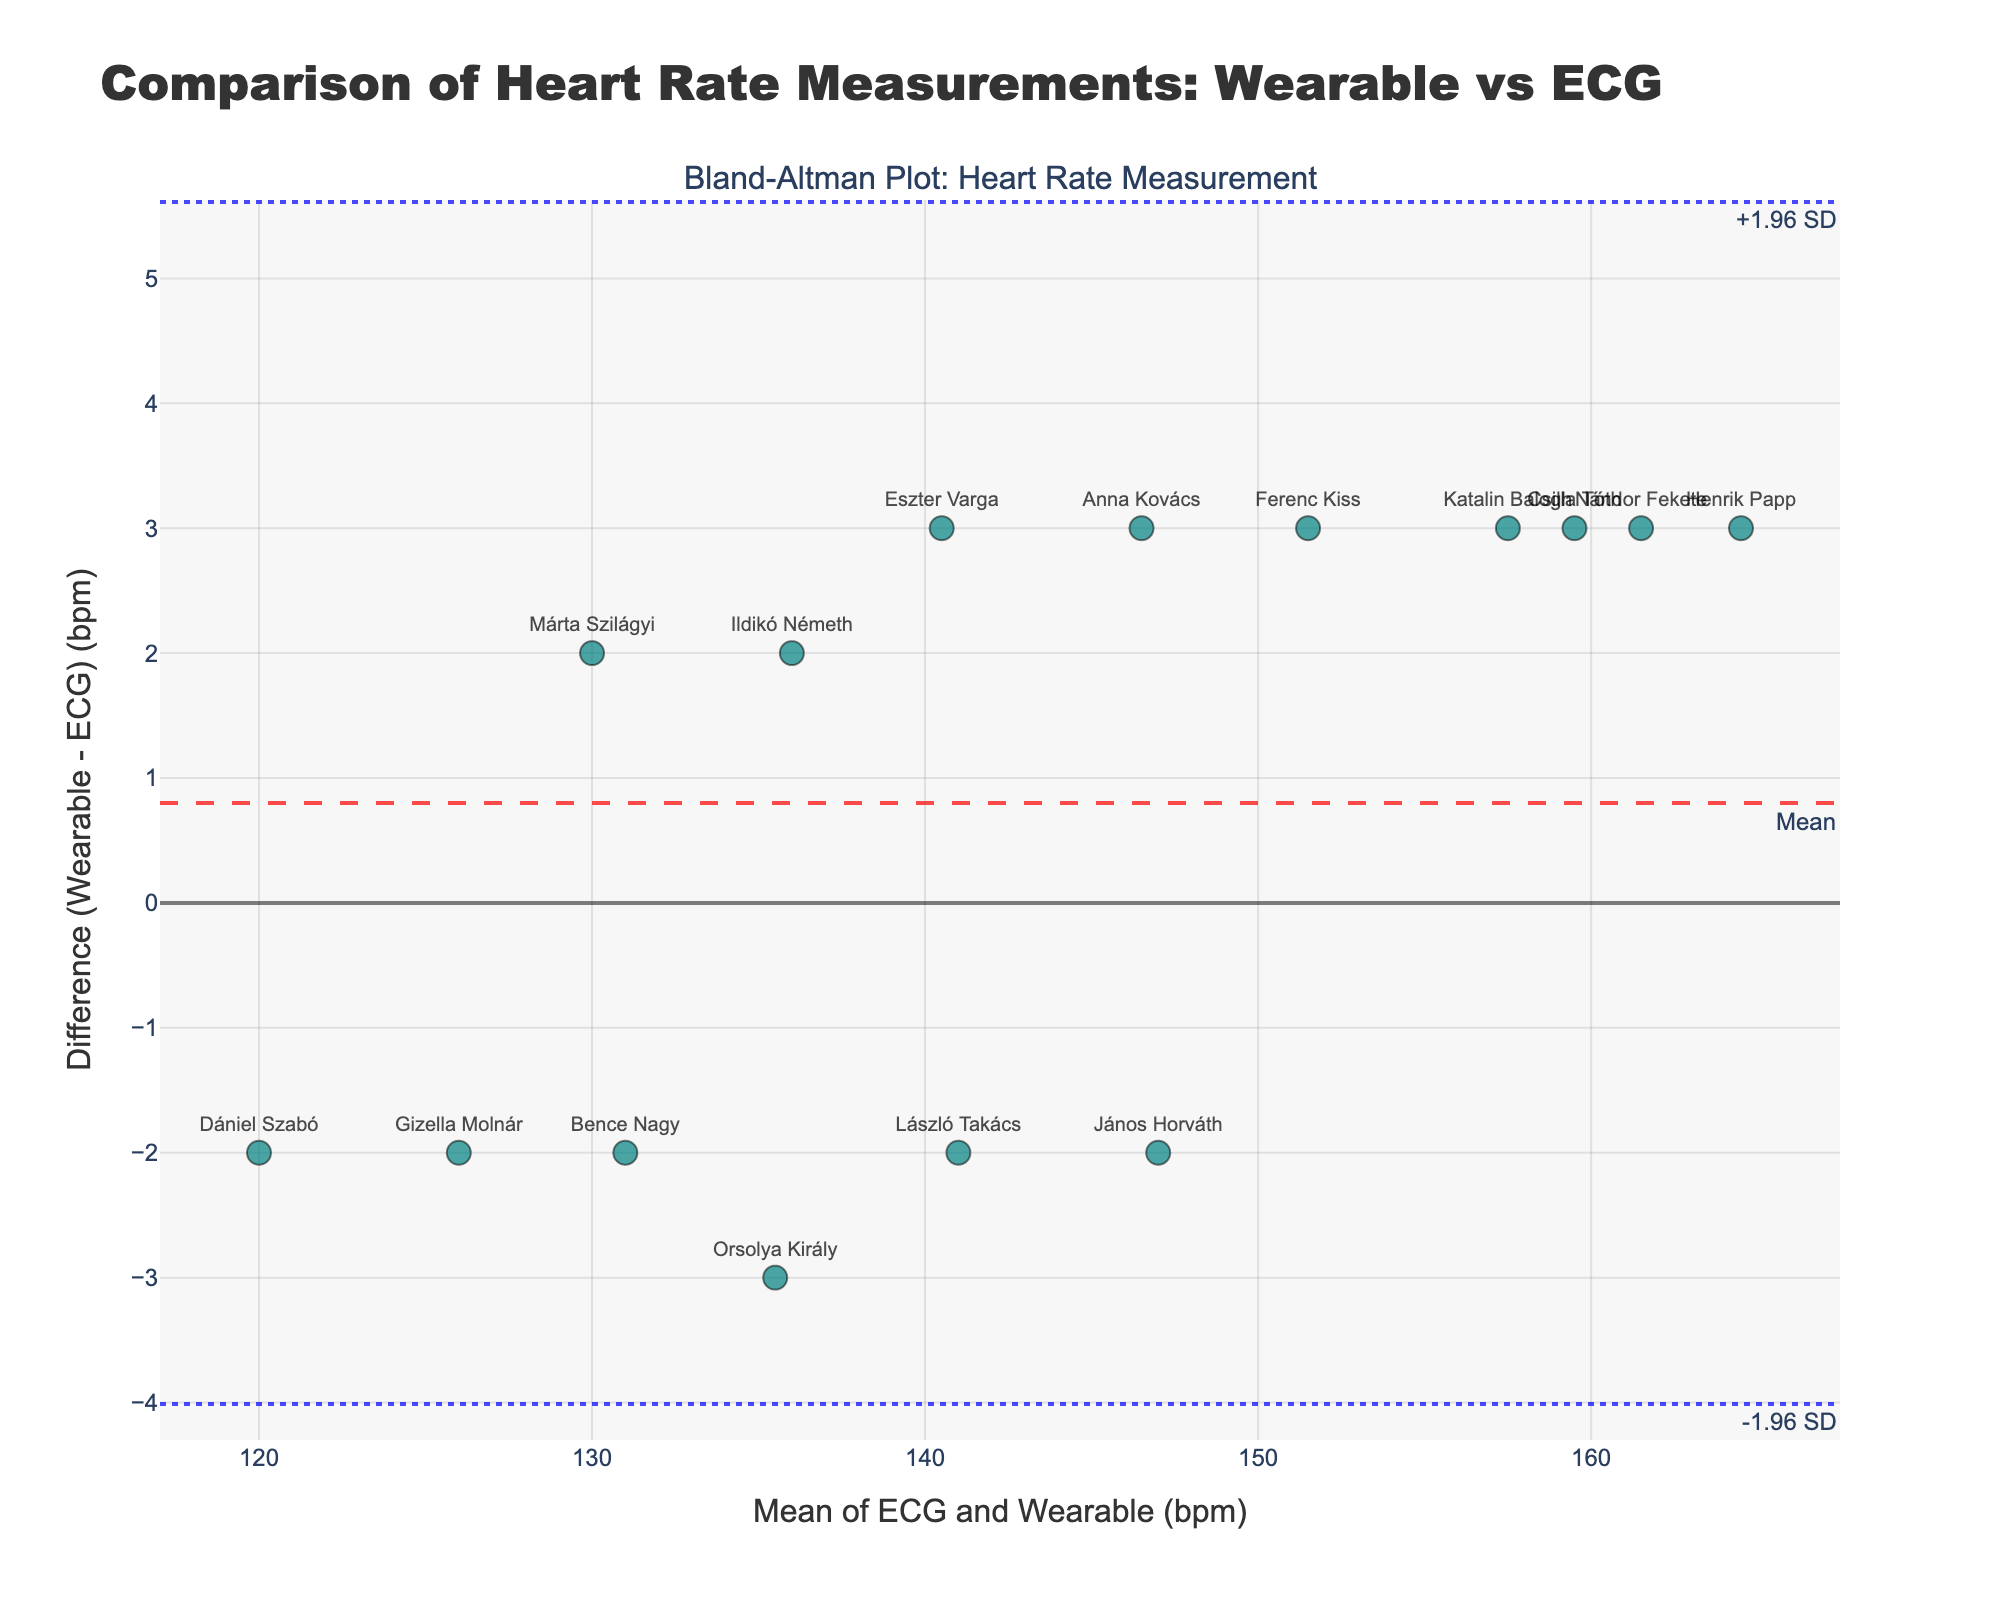What is the title of the plot? The title is generally found at the top of the plot, which provides a brief description of what the plot represents. This helps in quickly understanding the main focus of the figure.
Answer: Comparison of Heart Rate Measurements: Wearable vs ECG What do the x-axis and y-axis represent in the plot? The labels on the axes usually describe what each axis represents. The x-axis label is "Mean of ECG and Wearable (bpm)", and the y-axis label is "Difference (Wearable - ECG) (bpm)".
Answer: The x-axis represents "Mean of ECG and Wearable (bpm)", and the y-axis represents "Difference (Wearable - ECG) (bpm)" How many data points are there in the plot? By counting the number of markers or data points in the scatter part of the plot, we can determine how many individual measurements were compared.
Answer: 15 What is the mean difference between heart rate measurements by the wearable device and ECG? The mean difference line is typically highlighted in the plot, often annotated. This represents the average discrepancy between the two measurement methods.
Answer: Mean difference is around 2 bpm What are the upper and lower limits of agreement? The Bland-Altman plot usually shows the limits of agreement using dotted lines and often annotated. These limits are calculated as mean difference ± 1.96 * standard deviation of the differences.
Answer: Upper limit is approximately 5.92 bpm, and lower limit is approximately -1.92 bpm Which player has the largest difference between wearable and ECG measurements? By looking at the y-axis values of each data point and identifying the extreme value, we can determine which player has the maximum discrepancy.
Answer: Henrik Papp Who has the smallest difference between wearable and ECG measurements? Similarly, by identifying the data point closest to 0 on the y-axis, we can find the player with the smallest measurement difference.
Answer: László Takács What is the average heart rate measured by both devices for Ildikó Németh? Use Ildikó Németh's data point to find the average heart rate from the plotted mean value on the x-axis.
Answer: 136 bpm Is there any player whose difference is below the lower limit of agreement? Check if any data points fall below the lower limit of agreement line. This would identify outliers or significant discrepancies.
Answer: No What can you deduce if most data points lie within the limits of agreement? If most data points lie within ±1.96 standard deviations of the mean difference, it indicates good agreement between the two measurement methods. This means the wearable device is reasonably consistent with the ECG.
Answer: Good agreement between wearable and ECG 